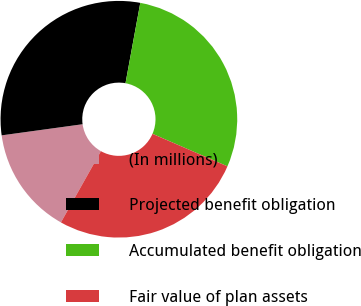Convert chart. <chart><loc_0><loc_0><loc_500><loc_500><pie_chart><fcel>(In millions)<fcel>Projected benefit obligation<fcel>Accumulated benefit obligation<fcel>Fair value of plan assets<nl><fcel>14.68%<fcel>30.07%<fcel>28.62%<fcel>26.63%<nl></chart> 